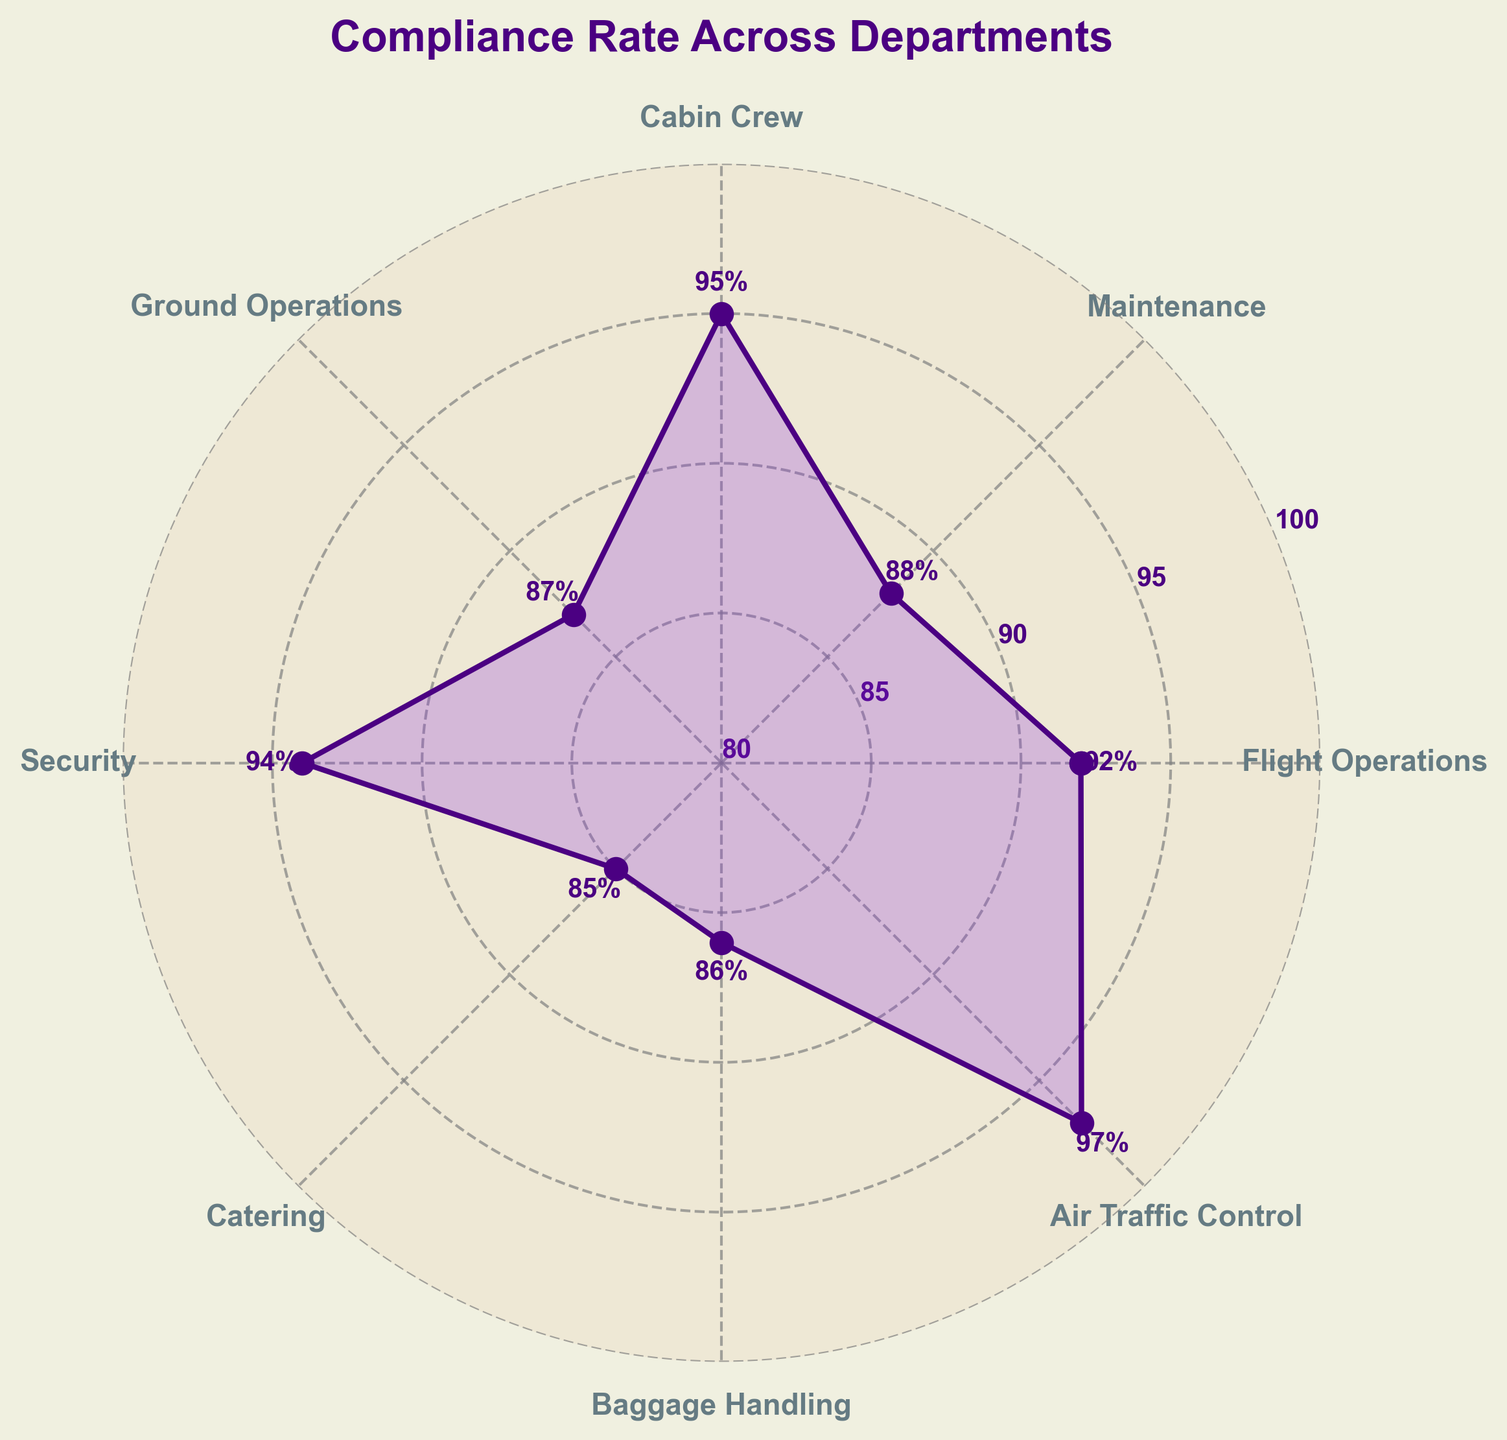Which department has the highest compliance rate? The department with the highest compliance rate is identified by finding the data point with the maximum value on the plot. The Air Traffic Control department has the highest rate at 97%.
Answer: Air Traffic Control Which department has the lowest compliance rate? The department with the lowest compliance rate is found by locating the data point with the minimum value on the plot. The Catering department has the lowest rate at 85%.
Answer: Catering What is the average compliance rate across all departments? The average compliance rate is calculated by summing all compliance rates and dividing by the number of departments. Sum of rates: 92 + 88 + 95 + 87 + 94 + 85 + 86 + 97 = 724. Number of departments = 8. Average = 724 / 8 = 90.5%
Answer: 90.5% How does the compliance rate of Flight Operations compare to Maintenance? The compliance rates for Flight Operations and Maintenance are 92% and 88% respectively. Thus, Flight Operations has a higher compliance rate than Maintenance by 4 percentage points.
Answer: Flight Operations is higher by 4% Which departments have a compliance rate above 90%? Departments with a compliance rate above 90% are identified by examining the values on the plot. They are Flight Operations (92%), Cabin Crew (95%), Security (94%), and Air Traffic Control (97%).
Answer: Flight Operations, Cabin Crew, Security, Air Traffic Control What is the range of compliance rates across the departments? The range is found by subtracting the lowest compliance rate from the highest. Highest rate: 97% (Air Traffic Control), Lowest rate: 85% (Catering). Range: 97 - 85 = 12 percentage points.
Answer: 12 percentage points How many departments have a compliance rate below the average compliance rate? First, we calculate the average compliance rate (90.5%). Departments with rates below this average are identified. They are Maintenance (88%), Ground Operations (87%), Catering (85%), and Baggage Handling (86%). Hence, there are 4 departments.
Answer: 4 Which two departments have the closest compliance rates? By comparing the rates, we find that Maintenance (88%) and Baggage Handling (86%) are the closest, with a difference of 2 percentage points.
Answer: Maintenance and Baggage Handling What is the compliance rate difference between Security and Cabin Crew? The compliance rates for Security and Cabin Crew are 94% and 95% respectively. The difference is calculated as 95 - 94 = 1 percentage point.
Answer: 1 percentage point How does the compliance rate of Ground Operations compare to the catering department? The compliance rates are 87% for Ground Operations and 85% for Catering. Ground Operations has a 2 percentage points higher rate than Catering.
Answer: Ground Operations is 2 points higher 